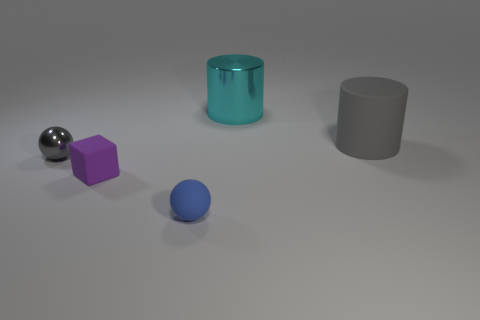Subtract 1 cylinders. How many cylinders are left? 1 Add 1 purple blocks. How many objects exist? 6 Subtract all cylinders. How many objects are left? 3 Add 5 tiny rubber spheres. How many tiny rubber spheres are left? 6 Add 5 yellow objects. How many yellow objects exist? 5 Subtract 0 yellow balls. How many objects are left? 5 Subtract all blue cylinders. Subtract all red blocks. How many cylinders are left? 2 Subtract all yellow blocks. How many cyan cylinders are left? 1 Subtract all blue spheres. Subtract all tiny blue matte objects. How many objects are left? 3 